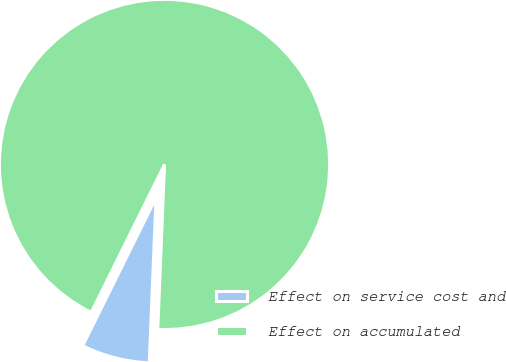Convert chart. <chart><loc_0><loc_0><loc_500><loc_500><pie_chart><fcel>Effect on service cost and<fcel>Effect on accumulated<nl><fcel>6.67%<fcel>93.33%<nl></chart> 